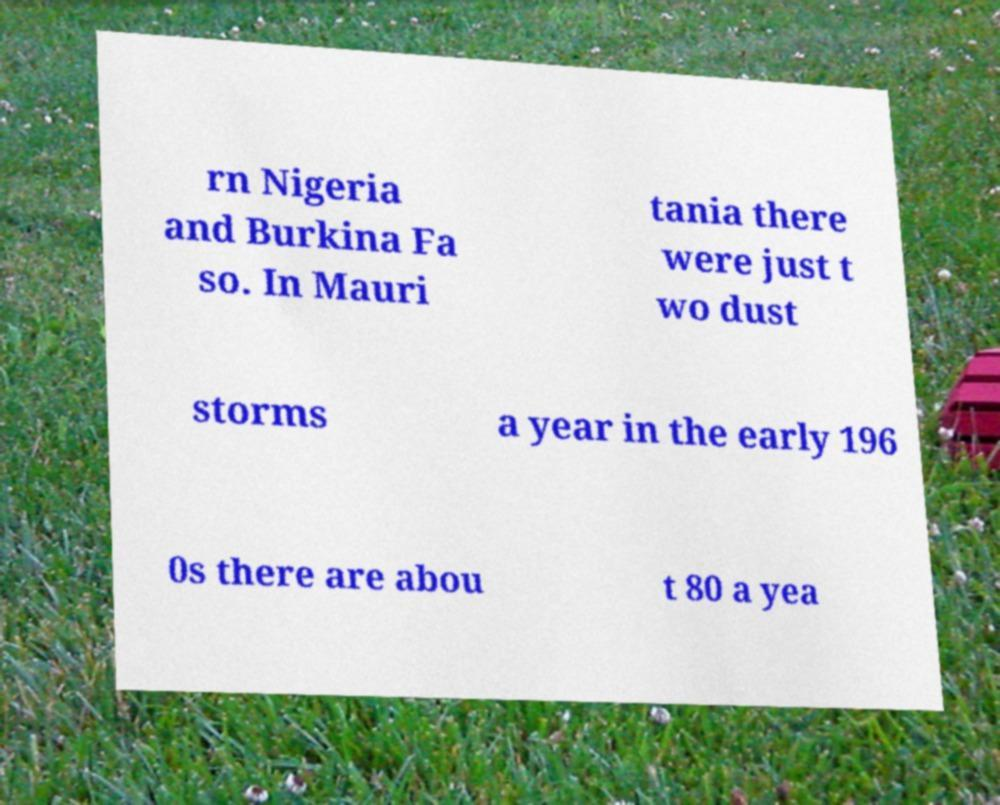For documentation purposes, I need the text within this image transcribed. Could you provide that? rn Nigeria and Burkina Fa so. In Mauri tania there were just t wo dust storms a year in the early 196 0s there are abou t 80 a yea 